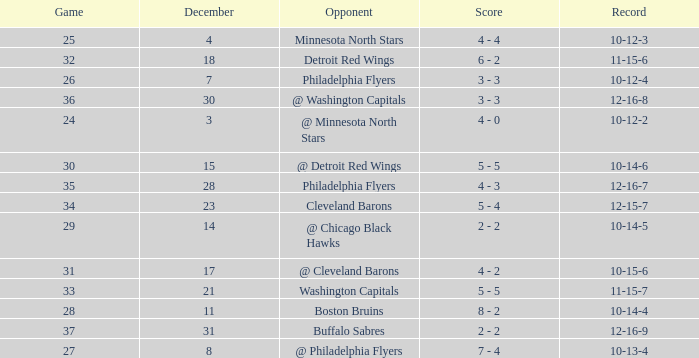What is the lowest December, when Score is "4 - 4"? 4.0. 